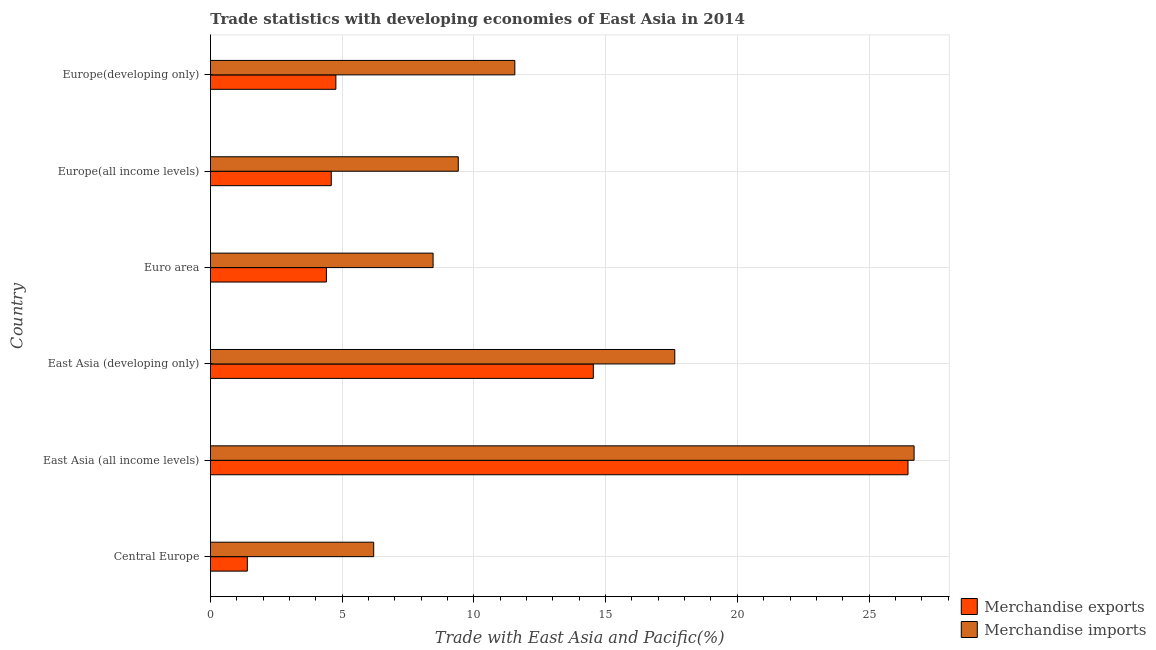How many different coloured bars are there?
Your response must be concise. 2. How many groups of bars are there?
Offer a terse response. 6. How many bars are there on the 2nd tick from the top?
Offer a terse response. 2. How many bars are there on the 5th tick from the bottom?
Offer a terse response. 2. What is the label of the 1st group of bars from the top?
Offer a terse response. Europe(developing only). What is the merchandise exports in East Asia (all income levels)?
Offer a terse response. 26.48. Across all countries, what is the maximum merchandise exports?
Provide a succinct answer. 26.48. Across all countries, what is the minimum merchandise exports?
Give a very brief answer. 1.4. In which country was the merchandise imports maximum?
Ensure brevity in your answer.  East Asia (all income levels). In which country was the merchandise exports minimum?
Provide a succinct answer. Central Europe. What is the total merchandise exports in the graph?
Make the answer very short. 56.16. What is the difference between the merchandise exports in Euro area and that in Europe(all income levels)?
Provide a short and direct response. -0.18. What is the difference between the merchandise exports in Europe(all income levels) and the merchandise imports in East Asia (developing only)?
Your response must be concise. -13.04. What is the average merchandise exports per country?
Your response must be concise. 9.36. What is the difference between the merchandise exports and merchandise imports in Europe(developing only)?
Provide a short and direct response. -6.79. In how many countries, is the merchandise exports greater than 9 %?
Your answer should be very brief. 2. What is the ratio of the merchandise exports in Central Europe to that in Europe(all income levels)?
Your answer should be compact. 0.3. Is the difference between the merchandise exports in Europe(all income levels) and Europe(developing only) greater than the difference between the merchandise imports in Europe(all income levels) and Europe(developing only)?
Your answer should be very brief. Yes. What is the difference between the highest and the second highest merchandise imports?
Offer a very short reply. 9.09. What is the difference between the highest and the lowest merchandise imports?
Keep it short and to the point. 20.51. Is the sum of the merchandise exports in East Asia (all income levels) and Europe(developing only) greater than the maximum merchandise imports across all countries?
Provide a succinct answer. Yes. What does the 1st bar from the top in Europe(all income levels) represents?
Ensure brevity in your answer.  Merchandise imports. What does the 2nd bar from the bottom in East Asia (all income levels) represents?
Ensure brevity in your answer.  Merchandise imports. Are all the bars in the graph horizontal?
Your response must be concise. Yes. How many countries are there in the graph?
Ensure brevity in your answer.  6. Are the values on the major ticks of X-axis written in scientific E-notation?
Your answer should be very brief. No. Does the graph contain any zero values?
Your answer should be very brief. No. Does the graph contain grids?
Offer a terse response. Yes. Where does the legend appear in the graph?
Your response must be concise. Bottom right. What is the title of the graph?
Keep it short and to the point. Trade statistics with developing economies of East Asia in 2014. What is the label or title of the X-axis?
Give a very brief answer. Trade with East Asia and Pacific(%). What is the label or title of the Y-axis?
Ensure brevity in your answer.  Country. What is the Trade with East Asia and Pacific(%) in Merchandise exports in Central Europe?
Offer a very short reply. 1.4. What is the Trade with East Asia and Pacific(%) in Merchandise imports in Central Europe?
Provide a succinct answer. 6.2. What is the Trade with East Asia and Pacific(%) of Merchandise exports in East Asia (all income levels)?
Give a very brief answer. 26.48. What is the Trade with East Asia and Pacific(%) in Merchandise imports in East Asia (all income levels)?
Provide a succinct answer. 26.71. What is the Trade with East Asia and Pacific(%) in Merchandise exports in East Asia (developing only)?
Make the answer very short. 14.53. What is the Trade with East Asia and Pacific(%) in Merchandise imports in East Asia (developing only)?
Offer a terse response. 17.63. What is the Trade with East Asia and Pacific(%) of Merchandise exports in Euro area?
Your answer should be compact. 4.4. What is the Trade with East Asia and Pacific(%) of Merchandise imports in Euro area?
Offer a very short reply. 8.45. What is the Trade with East Asia and Pacific(%) of Merchandise exports in Europe(all income levels)?
Offer a very short reply. 4.59. What is the Trade with East Asia and Pacific(%) in Merchandise imports in Europe(all income levels)?
Keep it short and to the point. 9.41. What is the Trade with East Asia and Pacific(%) in Merchandise exports in Europe(developing only)?
Give a very brief answer. 4.76. What is the Trade with East Asia and Pacific(%) of Merchandise imports in Europe(developing only)?
Your answer should be very brief. 11.55. Across all countries, what is the maximum Trade with East Asia and Pacific(%) in Merchandise exports?
Provide a short and direct response. 26.48. Across all countries, what is the maximum Trade with East Asia and Pacific(%) of Merchandise imports?
Your response must be concise. 26.71. Across all countries, what is the minimum Trade with East Asia and Pacific(%) in Merchandise exports?
Offer a very short reply. 1.4. Across all countries, what is the minimum Trade with East Asia and Pacific(%) in Merchandise imports?
Offer a very short reply. 6.2. What is the total Trade with East Asia and Pacific(%) of Merchandise exports in the graph?
Your answer should be compact. 56.16. What is the total Trade with East Asia and Pacific(%) in Merchandise imports in the graph?
Give a very brief answer. 79.94. What is the difference between the Trade with East Asia and Pacific(%) of Merchandise exports in Central Europe and that in East Asia (all income levels)?
Your answer should be very brief. -25.08. What is the difference between the Trade with East Asia and Pacific(%) in Merchandise imports in Central Europe and that in East Asia (all income levels)?
Keep it short and to the point. -20.51. What is the difference between the Trade with East Asia and Pacific(%) in Merchandise exports in Central Europe and that in East Asia (developing only)?
Provide a succinct answer. -13.13. What is the difference between the Trade with East Asia and Pacific(%) in Merchandise imports in Central Europe and that in East Asia (developing only)?
Keep it short and to the point. -11.43. What is the difference between the Trade with East Asia and Pacific(%) of Merchandise exports in Central Europe and that in Euro area?
Your answer should be very brief. -3. What is the difference between the Trade with East Asia and Pacific(%) in Merchandise imports in Central Europe and that in Euro area?
Provide a succinct answer. -2.25. What is the difference between the Trade with East Asia and Pacific(%) of Merchandise exports in Central Europe and that in Europe(all income levels)?
Your response must be concise. -3.19. What is the difference between the Trade with East Asia and Pacific(%) of Merchandise imports in Central Europe and that in Europe(all income levels)?
Ensure brevity in your answer.  -3.21. What is the difference between the Trade with East Asia and Pacific(%) of Merchandise exports in Central Europe and that in Europe(developing only)?
Make the answer very short. -3.36. What is the difference between the Trade with East Asia and Pacific(%) in Merchandise imports in Central Europe and that in Europe(developing only)?
Give a very brief answer. -5.36. What is the difference between the Trade with East Asia and Pacific(%) in Merchandise exports in East Asia (all income levels) and that in East Asia (developing only)?
Make the answer very short. 11.94. What is the difference between the Trade with East Asia and Pacific(%) in Merchandise imports in East Asia (all income levels) and that in East Asia (developing only)?
Keep it short and to the point. 9.08. What is the difference between the Trade with East Asia and Pacific(%) in Merchandise exports in East Asia (all income levels) and that in Euro area?
Offer a terse response. 22.08. What is the difference between the Trade with East Asia and Pacific(%) in Merchandise imports in East Asia (all income levels) and that in Euro area?
Make the answer very short. 18.26. What is the difference between the Trade with East Asia and Pacific(%) in Merchandise exports in East Asia (all income levels) and that in Europe(all income levels)?
Make the answer very short. 21.89. What is the difference between the Trade with East Asia and Pacific(%) in Merchandise imports in East Asia (all income levels) and that in Europe(all income levels)?
Your answer should be compact. 17.3. What is the difference between the Trade with East Asia and Pacific(%) in Merchandise exports in East Asia (all income levels) and that in Europe(developing only)?
Offer a terse response. 21.72. What is the difference between the Trade with East Asia and Pacific(%) of Merchandise imports in East Asia (all income levels) and that in Europe(developing only)?
Your answer should be very brief. 15.16. What is the difference between the Trade with East Asia and Pacific(%) of Merchandise exports in East Asia (developing only) and that in Euro area?
Your answer should be compact. 10.13. What is the difference between the Trade with East Asia and Pacific(%) in Merchandise imports in East Asia (developing only) and that in Euro area?
Your answer should be very brief. 9.17. What is the difference between the Trade with East Asia and Pacific(%) of Merchandise exports in East Asia (developing only) and that in Europe(all income levels)?
Your answer should be very brief. 9.95. What is the difference between the Trade with East Asia and Pacific(%) in Merchandise imports in East Asia (developing only) and that in Europe(all income levels)?
Offer a very short reply. 8.22. What is the difference between the Trade with East Asia and Pacific(%) of Merchandise exports in East Asia (developing only) and that in Europe(developing only)?
Make the answer very short. 9.77. What is the difference between the Trade with East Asia and Pacific(%) in Merchandise imports in East Asia (developing only) and that in Europe(developing only)?
Your answer should be very brief. 6.07. What is the difference between the Trade with East Asia and Pacific(%) in Merchandise exports in Euro area and that in Europe(all income levels)?
Provide a short and direct response. -0.18. What is the difference between the Trade with East Asia and Pacific(%) of Merchandise imports in Euro area and that in Europe(all income levels)?
Your response must be concise. -0.96. What is the difference between the Trade with East Asia and Pacific(%) in Merchandise exports in Euro area and that in Europe(developing only)?
Your answer should be compact. -0.36. What is the difference between the Trade with East Asia and Pacific(%) of Merchandise imports in Euro area and that in Europe(developing only)?
Your answer should be compact. -3.1. What is the difference between the Trade with East Asia and Pacific(%) in Merchandise exports in Europe(all income levels) and that in Europe(developing only)?
Keep it short and to the point. -0.18. What is the difference between the Trade with East Asia and Pacific(%) in Merchandise imports in Europe(all income levels) and that in Europe(developing only)?
Provide a succinct answer. -2.15. What is the difference between the Trade with East Asia and Pacific(%) of Merchandise exports in Central Europe and the Trade with East Asia and Pacific(%) of Merchandise imports in East Asia (all income levels)?
Make the answer very short. -25.31. What is the difference between the Trade with East Asia and Pacific(%) in Merchandise exports in Central Europe and the Trade with East Asia and Pacific(%) in Merchandise imports in East Asia (developing only)?
Provide a succinct answer. -16.23. What is the difference between the Trade with East Asia and Pacific(%) of Merchandise exports in Central Europe and the Trade with East Asia and Pacific(%) of Merchandise imports in Euro area?
Provide a short and direct response. -7.05. What is the difference between the Trade with East Asia and Pacific(%) of Merchandise exports in Central Europe and the Trade with East Asia and Pacific(%) of Merchandise imports in Europe(all income levels)?
Provide a short and direct response. -8.01. What is the difference between the Trade with East Asia and Pacific(%) of Merchandise exports in Central Europe and the Trade with East Asia and Pacific(%) of Merchandise imports in Europe(developing only)?
Provide a short and direct response. -10.15. What is the difference between the Trade with East Asia and Pacific(%) of Merchandise exports in East Asia (all income levels) and the Trade with East Asia and Pacific(%) of Merchandise imports in East Asia (developing only)?
Offer a very short reply. 8.85. What is the difference between the Trade with East Asia and Pacific(%) in Merchandise exports in East Asia (all income levels) and the Trade with East Asia and Pacific(%) in Merchandise imports in Euro area?
Offer a very short reply. 18.03. What is the difference between the Trade with East Asia and Pacific(%) of Merchandise exports in East Asia (all income levels) and the Trade with East Asia and Pacific(%) of Merchandise imports in Europe(all income levels)?
Provide a short and direct response. 17.07. What is the difference between the Trade with East Asia and Pacific(%) of Merchandise exports in East Asia (all income levels) and the Trade with East Asia and Pacific(%) of Merchandise imports in Europe(developing only)?
Offer a very short reply. 14.93. What is the difference between the Trade with East Asia and Pacific(%) in Merchandise exports in East Asia (developing only) and the Trade with East Asia and Pacific(%) in Merchandise imports in Euro area?
Provide a succinct answer. 6.08. What is the difference between the Trade with East Asia and Pacific(%) of Merchandise exports in East Asia (developing only) and the Trade with East Asia and Pacific(%) of Merchandise imports in Europe(all income levels)?
Offer a very short reply. 5.13. What is the difference between the Trade with East Asia and Pacific(%) in Merchandise exports in East Asia (developing only) and the Trade with East Asia and Pacific(%) in Merchandise imports in Europe(developing only)?
Provide a succinct answer. 2.98. What is the difference between the Trade with East Asia and Pacific(%) of Merchandise exports in Euro area and the Trade with East Asia and Pacific(%) of Merchandise imports in Europe(all income levels)?
Give a very brief answer. -5.01. What is the difference between the Trade with East Asia and Pacific(%) of Merchandise exports in Euro area and the Trade with East Asia and Pacific(%) of Merchandise imports in Europe(developing only)?
Provide a succinct answer. -7.15. What is the difference between the Trade with East Asia and Pacific(%) of Merchandise exports in Europe(all income levels) and the Trade with East Asia and Pacific(%) of Merchandise imports in Europe(developing only)?
Give a very brief answer. -6.97. What is the average Trade with East Asia and Pacific(%) of Merchandise exports per country?
Make the answer very short. 9.36. What is the average Trade with East Asia and Pacific(%) of Merchandise imports per country?
Make the answer very short. 13.32. What is the difference between the Trade with East Asia and Pacific(%) in Merchandise exports and Trade with East Asia and Pacific(%) in Merchandise imports in Central Europe?
Your response must be concise. -4.8. What is the difference between the Trade with East Asia and Pacific(%) in Merchandise exports and Trade with East Asia and Pacific(%) in Merchandise imports in East Asia (all income levels)?
Keep it short and to the point. -0.23. What is the difference between the Trade with East Asia and Pacific(%) in Merchandise exports and Trade with East Asia and Pacific(%) in Merchandise imports in East Asia (developing only)?
Provide a succinct answer. -3.09. What is the difference between the Trade with East Asia and Pacific(%) of Merchandise exports and Trade with East Asia and Pacific(%) of Merchandise imports in Euro area?
Offer a terse response. -4.05. What is the difference between the Trade with East Asia and Pacific(%) of Merchandise exports and Trade with East Asia and Pacific(%) of Merchandise imports in Europe(all income levels)?
Provide a short and direct response. -4.82. What is the difference between the Trade with East Asia and Pacific(%) in Merchandise exports and Trade with East Asia and Pacific(%) in Merchandise imports in Europe(developing only)?
Make the answer very short. -6.79. What is the ratio of the Trade with East Asia and Pacific(%) of Merchandise exports in Central Europe to that in East Asia (all income levels)?
Provide a short and direct response. 0.05. What is the ratio of the Trade with East Asia and Pacific(%) in Merchandise imports in Central Europe to that in East Asia (all income levels)?
Offer a terse response. 0.23. What is the ratio of the Trade with East Asia and Pacific(%) in Merchandise exports in Central Europe to that in East Asia (developing only)?
Offer a terse response. 0.1. What is the ratio of the Trade with East Asia and Pacific(%) of Merchandise imports in Central Europe to that in East Asia (developing only)?
Offer a very short reply. 0.35. What is the ratio of the Trade with East Asia and Pacific(%) in Merchandise exports in Central Europe to that in Euro area?
Provide a succinct answer. 0.32. What is the ratio of the Trade with East Asia and Pacific(%) of Merchandise imports in Central Europe to that in Euro area?
Your answer should be very brief. 0.73. What is the ratio of the Trade with East Asia and Pacific(%) of Merchandise exports in Central Europe to that in Europe(all income levels)?
Ensure brevity in your answer.  0.31. What is the ratio of the Trade with East Asia and Pacific(%) of Merchandise imports in Central Europe to that in Europe(all income levels)?
Provide a succinct answer. 0.66. What is the ratio of the Trade with East Asia and Pacific(%) in Merchandise exports in Central Europe to that in Europe(developing only)?
Make the answer very short. 0.29. What is the ratio of the Trade with East Asia and Pacific(%) of Merchandise imports in Central Europe to that in Europe(developing only)?
Give a very brief answer. 0.54. What is the ratio of the Trade with East Asia and Pacific(%) of Merchandise exports in East Asia (all income levels) to that in East Asia (developing only)?
Give a very brief answer. 1.82. What is the ratio of the Trade with East Asia and Pacific(%) of Merchandise imports in East Asia (all income levels) to that in East Asia (developing only)?
Your response must be concise. 1.52. What is the ratio of the Trade with East Asia and Pacific(%) in Merchandise exports in East Asia (all income levels) to that in Euro area?
Your answer should be compact. 6.02. What is the ratio of the Trade with East Asia and Pacific(%) of Merchandise imports in East Asia (all income levels) to that in Euro area?
Provide a succinct answer. 3.16. What is the ratio of the Trade with East Asia and Pacific(%) of Merchandise exports in East Asia (all income levels) to that in Europe(all income levels)?
Ensure brevity in your answer.  5.77. What is the ratio of the Trade with East Asia and Pacific(%) in Merchandise imports in East Asia (all income levels) to that in Europe(all income levels)?
Provide a short and direct response. 2.84. What is the ratio of the Trade with East Asia and Pacific(%) in Merchandise exports in East Asia (all income levels) to that in Europe(developing only)?
Keep it short and to the point. 5.56. What is the ratio of the Trade with East Asia and Pacific(%) in Merchandise imports in East Asia (all income levels) to that in Europe(developing only)?
Your answer should be compact. 2.31. What is the ratio of the Trade with East Asia and Pacific(%) of Merchandise exports in East Asia (developing only) to that in Euro area?
Make the answer very short. 3.3. What is the ratio of the Trade with East Asia and Pacific(%) in Merchandise imports in East Asia (developing only) to that in Euro area?
Your answer should be very brief. 2.09. What is the ratio of the Trade with East Asia and Pacific(%) of Merchandise exports in East Asia (developing only) to that in Europe(all income levels)?
Your response must be concise. 3.17. What is the ratio of the Trade with East Asia and Pacific(%) of Merchandise imports in East Asia (developing only) to that in Europe(all income levels)?
Make the answer very short. 1.87. What is the ratio of the Trade with East Asia and Pacific(%) of Merchandise exports in East Asia (developing only) to that in Europe(developing only)?
Offer a terse response. 3.05. What is the ratio of the Trade with East Asia and Pacific(%) of Merchandise imports in East Asia (developing only) to that in Europe(developing only)?
Your answer should be very brief. 1.53. What is the ratio of the Trade with East Asia and Pacific(%) of Merchandise exports in Euro area to that in Europe(all income levels)?
Provide a succinct answer. 0.96. What is the ratio of the Trade with East Asia and Pacific(%) in Merchandise imports in Euro area to that in Europe(all income levels)?
Offer a very short reply. 0.9. What is the ratio of the Trade with East Asia and Pacific(%) in Merchandise exports in Euro area to that in Europe(developing only)?
Ensure brevity in your answer.  0.92. What is the ratio of the Trade with East Asia and Pacific(%) in Merchandise imports in Euro area to that in Europe(developing only)?
Keep it short and to the point. 0.73. What is the ratio of the Trade with East Asia and Pacific(%) of Merchandise exports in Europe(all income levels) to that in Europe(developing only)?
Ensure brevity in your answer.  0.96. What is the ratio of the Trade with East Asia and Pacific(%) of Merchandise imports in Europe(all income levels) to that in Europe(developing only)?
Your response must be concise. 0.81. What is the difference between the highest and the second highest Trade with East Asia and Pacific(%) of Merchandise exports?
Make the answer very short. 11.94. What is the difference between the highest and the second highest Trade with East Asia and Pacific(%) in Merchandise imports?
Make the answer very short. 9.08. What is the difference between the highest and the lowest Trade with East Asia and Pacific(%) of Merchandise exports?
Keep it short and to the point. 25.08. What is the difference between the highest and the lowest Trade with East Asia and Pacific(%) in Merchandise imports?
Your answer should be very brief. 20.51. 